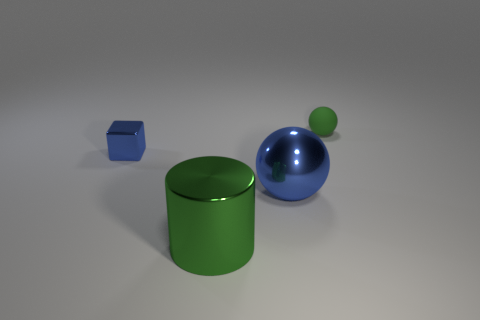What number of other objects are there of the same size as the block? Based on the visual comparison, there are no other objects of the exact same size as the blue block. Each object has a distinct size; the green cylinder and the blue sphere are larger, whereas the small green sphere is smaller than the block in question. 